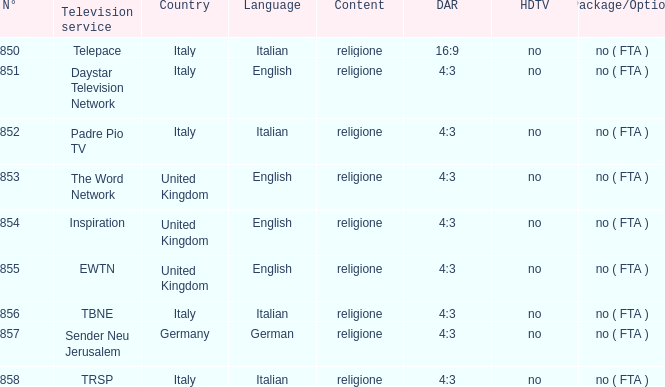What television service is in italy and is in english? Daystar Television Network. 